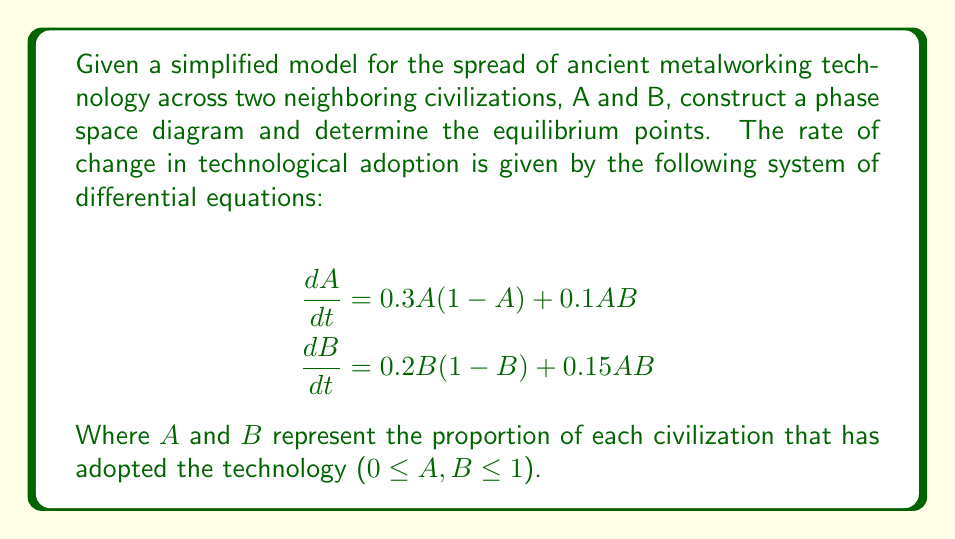Show me your answer to this math problem. To construct the phase space diagram and find the equilibrium points, we'll follow these steps:

1. Identify the nullclines:
   Set $\frac{dA}{dt} = 0$ and $\frac{dB}{dt} = 0$ to find the nullclines.

   For A: $0.3A(1-A) + 0.1AB = 0$
          $A(0.3 - 0.3A + 0.1B) = 0$
          $A = 0$ or $B = 3 - 3A$

   For B: $0.2B(1-B) + 0.15AB = 0$
          $B(0.2 - 0.2B + 0.15A) = 0$
          $B = 0$ or $A = \frac{4B - 4}{3}$

2. Find the intersection points of the nullclines to determine equilibrium points:
   (0, 0), (1, 0), (0, 1), and the intersection of $B = 3 - 3A$ and $A = \frac{4B - 4}{3}$

   Solving: $B = 3 - 3(\frac{4B - 4}{3})$
            $B = 3 - 4B + 4$
            $5B = 7$
            $B = \frac{7}{5}$
   
   Substituting back: $A = \frac{4(\frac{7}{5}) - 4}{3} = \frac{28 - 20}{15} = \frac{8}{15}$

   The fourth equilibrium point is $(\frac{8}{15}, \frac{7}{5})$, which is outside the valid range for B.

3. Sketch the nullclines and mark the equilibrium points:

[asy]
import graph;
size(200);
xaxis("A", 0, 1, Arrow);
yaxis("B", 0, 1, Arrow);

draw((0,0)--(1,0), green);
draw((0,1)--(1,1), green);
draw((0,0)--(0,1), red);
draw((1,0)--(1,1), red);

draw((0,3)--(1,0), green+dashed);
draw((0,0)--(0.75,1), red+dashed);

dot((0,0));
dot((1,0));
dot((0,1));

label("(0,0)", (0,0), SW);
label("(1,0)", (1,0), SE);
label("(0,1)", (0,1), NW);

[/asy]

4. Analyze the vector field:
   - At (0,0): Both populations remain at 0 (stable)
   - At (1,0) and (0,1): One population dominates, the other remains at 0 (unstable)
   - The vector field generally points towards increasing adoption for both civilizations

5. Draw representative trajectories based on the vector field analysis.
Answer: Equilibrium points: (0,0), (1,0), (0,1); Stable equilibrium: (0,0) 